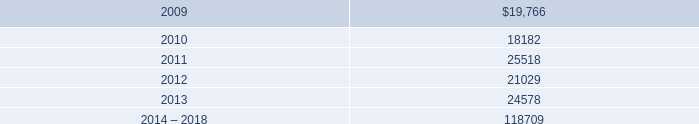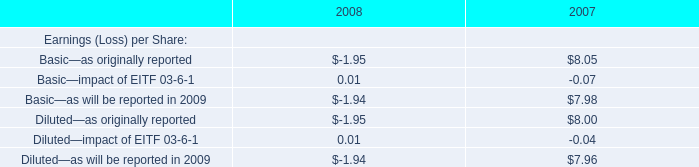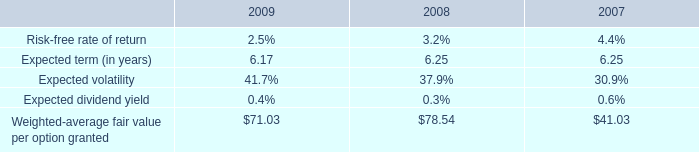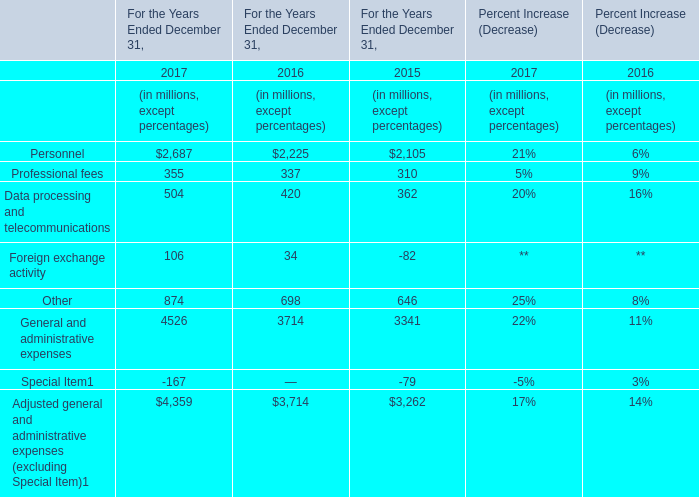considering the years 2007-2008 , what was the increase observed in the expense related to all of the defined contribution plans? 
Computations: ((35341 / 26996) - 1)
Answer: 0.30912. 